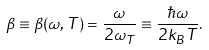Convert formula to latex. <formula><loc_0><loc_0><loc_500><loc_500>\beta \equiv \beta ( \omega , T ) = \frac { \omega } { 2 \omega _ { T } } \equiv \frac { \hbar { \omega } } { 2 k _ { B } T } .</formula> 